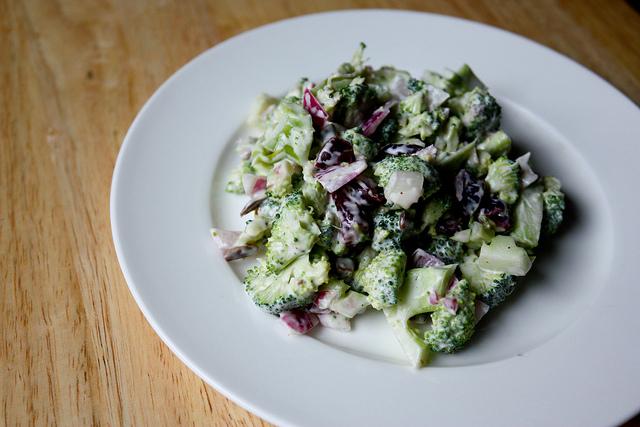What kind of salad is this?
Quick response, please. Broccoli. What is the plate sitting on?
Short answer required. Table. Would this be suitable to serve to a vegetarian?
Concise answer only. Yes. What color is the broccoli?
Answer briefly. Green. What is this food called?
Concise answer only. Salad. What color is the plate?
Be succinct. White. How is the broccoli cooked?
Keep it brief. Raw. 